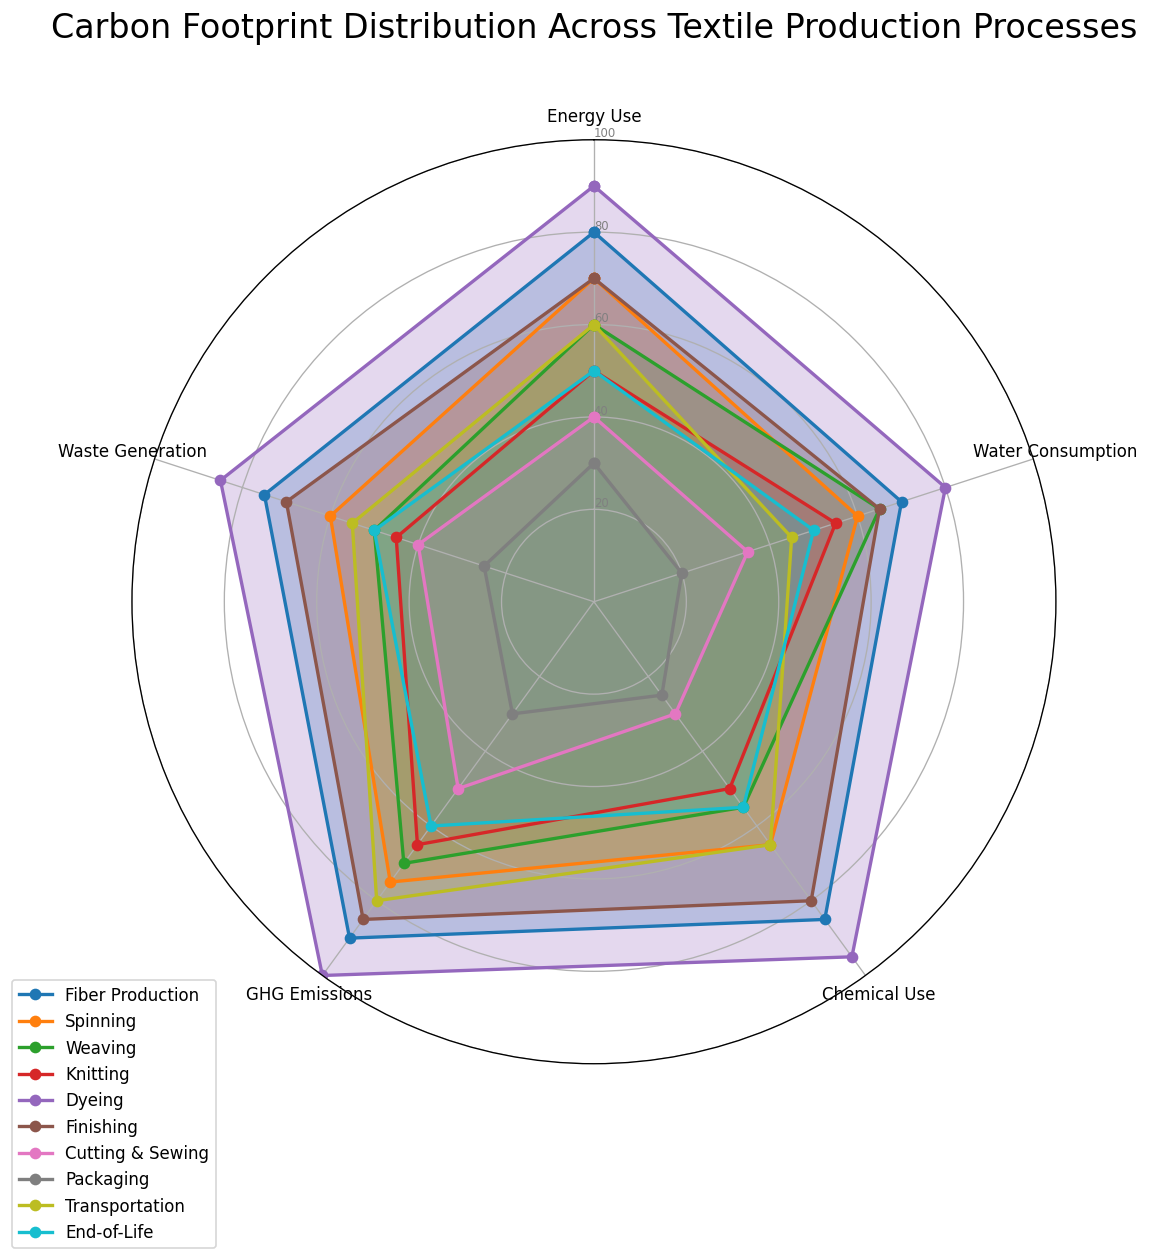Which process has the highest GHG Emissions? Looking at the radar chart, identify the line that reaches the highest point in the GHG Emissions category. Dyeing has the highest value reaching 100.
Answer: Dyeing Which process uses the least amount of water? Observe the Water Consumption axis and find the line that is closest to the center. Packaging has the least amount of water consumption at 20.
Answer: Packaging Which processes have an equal amount of GHG Emissions and Waste Generation? Compare the GHG Emissions and Waste Generation values for each process and find the ones where the values match. End-of-Life has equal GHG Emissions and Waste Generation at 50.
Answer: End-of-Life What is the average Energy Use of Fiber Production, Dyeing, and Finishing? Sum the Energy Use values for Fiber Production (80), Dyeing (90), and Finishing (70), then divide by 3. The calculation is (80 + 90 + 70) / 3 = 240 / 3 = 80.
Answer: 80 Which process has the widest range between its highest and lowest values? Examine the radar chart lines for each process and calculate the range (difference between highest and lowest values). Dyeing has the widest range with the highest value at 100 and the lowest at 80, resulting in a range of 100 - 80 = 20.
Answer: Dyeing Which process contributes the most to Chemical Use and how does it compare to the same process's Waste Generation? Locate the Chemical Use axis to identify the highest value and note the process. Dyeing has the highest Chemical Use at 95. Then, check the Waste Generation value for Dyeing, which is 85. Therefore, Dyeing has 10 more in Chemical Use compared to Waste Generation.
Answer: Dyeing, 10 more How many processes have a Water Consumption value of 65 or higher? Count the number of processes with Water Consumption values at or above 65 by observing the Water Consumption axis. Fiber Production, Dyeing, and Finishing have values of 70, 80, and 65 respectively, and Weaving has 65. Therefore, there are 4 processes.
Answer: 4 Find the sum of Energy Use for Spinning, Weaving, and Knitting. Add the Energy Use values for Spinning (70), Weaving (60), and Knitting (50). The calculation is 70 + 60 + 50 = 180.
Answer: 180 Which process has the lowest values across the most categories? Identify the process with the most categories having values closest to the center of the radar chart. Packaging has the lowest values across the most categories, with four values in the range of 20-30.
Answer: Packaging Compare the GHG Emissions between Spinning and Transportation and determine the higher value. Locate the GHG Emissions category for both Spinning (75) and Transportation (80) and compare. Transportation has a higher value.
Answer: Transportation 